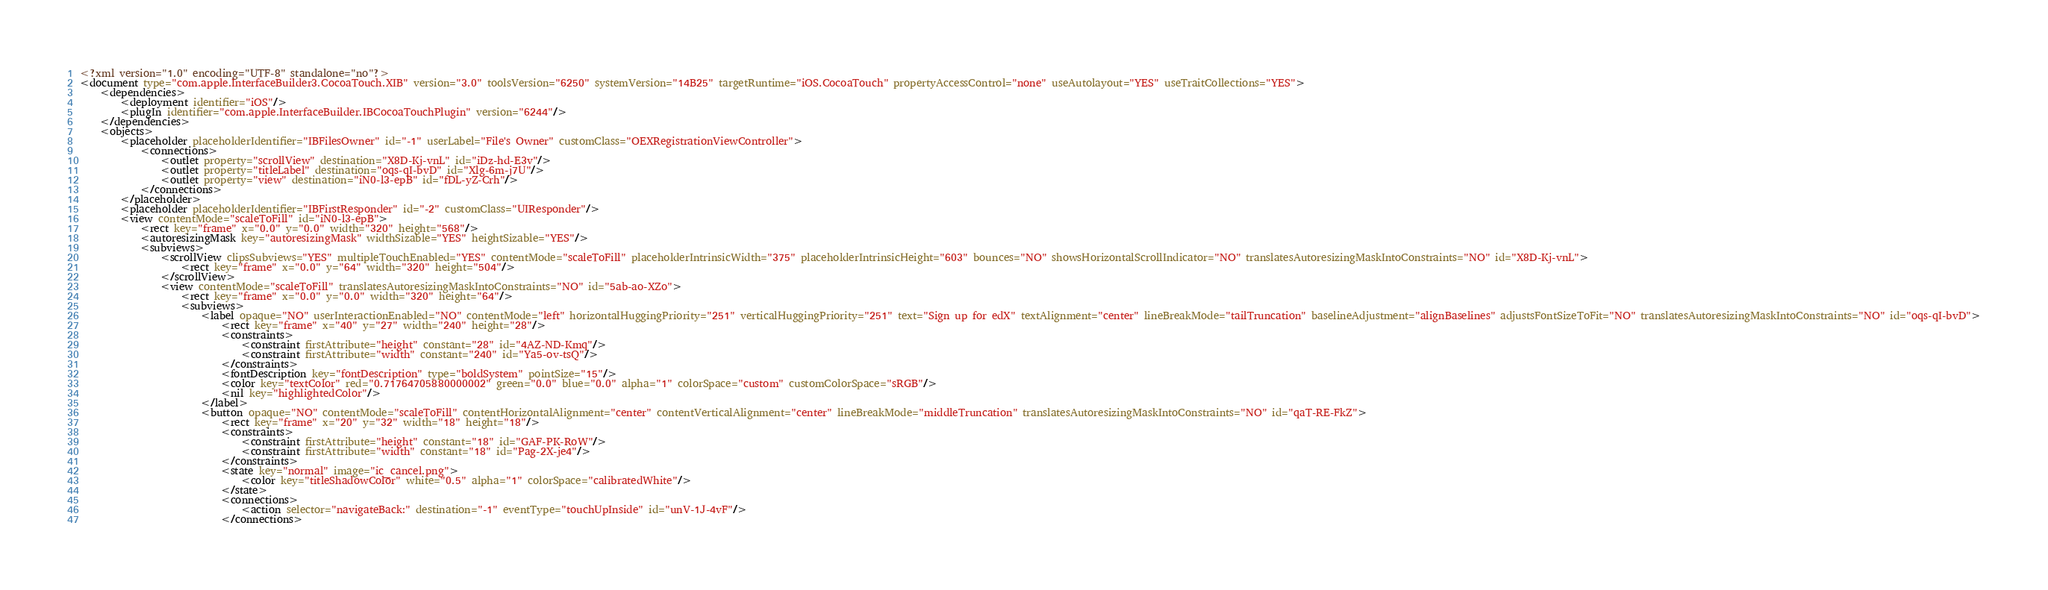Convert code to text. <code><loc_0><loc_0><loc_500><loc_500><_XML_><?xml version="1.0" encoding="UTF-8" standalone="no"?>
<document type="com.apple.InterfaceBuilder3.CocoaTouch.XIB" version="3.0" toolsVersion="6250" systemVersion="14B25" targetRuntime="iOS.CocoaTouch" propertyAccessControl="none" useAutolayout="YES" useTraitCollections="YES">
    <dependencies>
        <deployment identifier="iOS"/>
        <plugIn identifier="com.apple.InterfaceBuilder.IBCocoaTouchPlugin" version="6244"/>
    </dependencies>
    <objects>
        <placeholder placeholderIdentifier="IBFilesOwner" id="-1" userLabel="File's Owner" customClass="OEXRegistrationViewController">
            <connections>
                <outlet property="scrollView" destination="X8D-Kj-vnL" id="iDz-hd-E3v"/>
                <outlet property="titleLabel" destination="oqs-qI-bvD" id="Xlg-6m-j7U"/>
                <outlet property="view" destination="iN0-l3-epB" id="fDL-yZ-Crh"/>
            </connections>
        </placeholder>
        <placeholder placeholderIdentifier="IBFirstResponder" id="-2" customClass="UIResponder"/>
        <view contentMode="scaleToFill" id="iN0-l3-epB">
            <rect key="frame" x="0.0" y="0.0" width="320" height="568"/>
            <autoresizingMask key="autoresizingMask" widthSizable="YES" heightSizable="YES"/>
            <subviews>
                <scrollView clipsSubviews="YES" multipleTouchEnabled="YES" contentMode="scaleToFill" placeholderIntrinsicWidth="375" placeholderIntrinsicHeight="603" bounces="NO" showsHorizontalScrollIndicator="NO" translatesAutoresizingMaskIntoConstraints="NO" id="X8D-Kj-vnL">
                    <rect key="frame" x="0.0" y="64" width="320" height="504"/>
                </scrollView>
                <view contentMode="scaleToFill" translatesAutoresizingMaskIntoConstraints="NO" id="5ab-ao-XZo">
                    <rect key="frame" x="0.0" y="0.0" width="320" height="64"/>
                    <subviews>
                        <label opaque="NO" userInteractionEnabled="NO" contentMode="left" horizontalHuggingPriority="251" verticalHuggingPriority="251" text="Sign up for edX" textAlignment="center" lineBreakMode="tailTruncation" baselineAdjustment="alignBaselines" adjustsFontSizeToFit="NO" translatesAutoresizingMaskIntoConstraints="NO" id="oqs-qI-bvD">
                            <rect key="frame" x="40" y="27" width="240" height="28"/>
                            <constraints>
                                <constraint firstAttribute="height" constant="28" id="4AZ-ND-Kmq"/>
                                <constraint firstAttribute="width" constant="240" id="Ya5-ov-tsQ"/>
                            </constraints>
                            <fontDescription key="fontDescription" type="boldSystem" pointSize="15"/>
                            <color key="textColor" red="0.71764705880000002" green="0.0" blue="0.0" alpha="1" colorSpace="custom" customColorSpace="sRGB"/>
                            <nil key="highlightedColor"/>
                        </label>
                        <button opaque="NO" contentMode="scaleToFill" contentHorizontalAlignment="center" contentVerticalAlignment="center" lineBreakMode="middleTruncation" translatesAutoresizingMaskIntoConstraints="NO" id="qaT-RE-FkZ">
                            <rect key="frame" x="20" y="32" width="18" height="18"/>
                            <constraints>
                                <constraint firstAttribute="height" constant="18" id="GAF-PK-RoW"/>
                                <constraint firstAttribute="width" constant="18" id="Pag-2X-je4"/>
                            </constraints>
                            <state key="normal" image="ic_cancel.png">
                                <color key="titleShadowColor" white="0.5" alpha="1" colorSpace="calibratedWhite"/>
                            </state>
                            <connections>
                                <action selector="navigateBack:" destination="-1" eventType="touchUpInside" id="unV-1J-4vF"/>
                            </connections></code> 